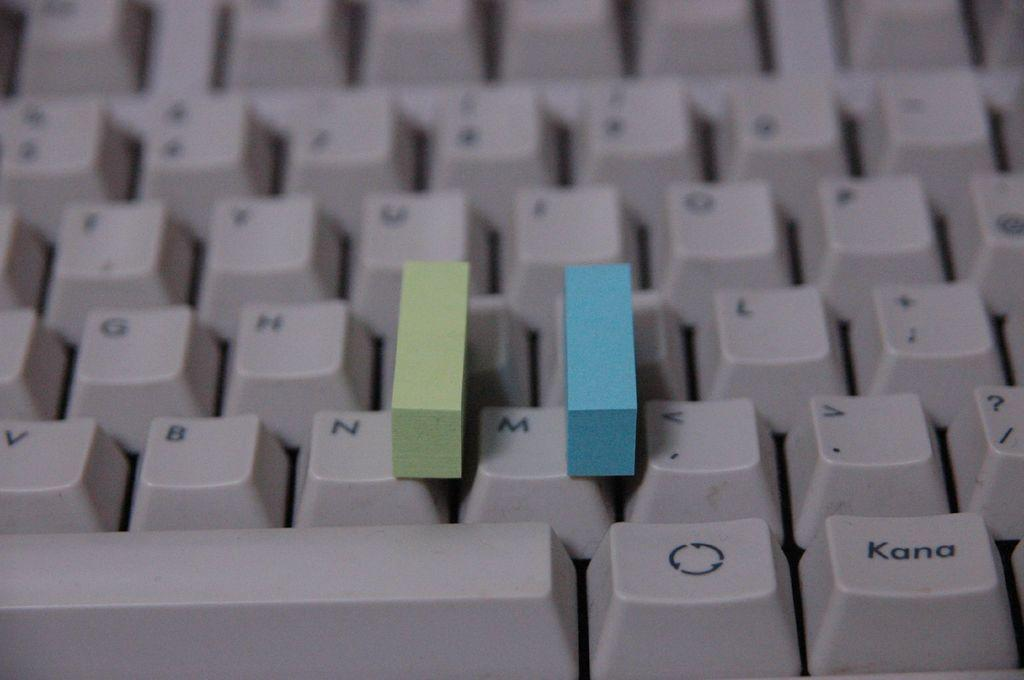<image>
Render a clear and concise summary of the photo. A green and a blue box are on either side of the M key on a keyboard. 